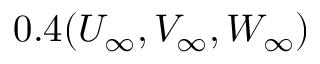<formula> <loc_0><loc_0><loc_500><loc_500>0 . 4 ( { U _ { \infty } } , { V _ { \infty } } , { W _ { \infty } } )</formula> 